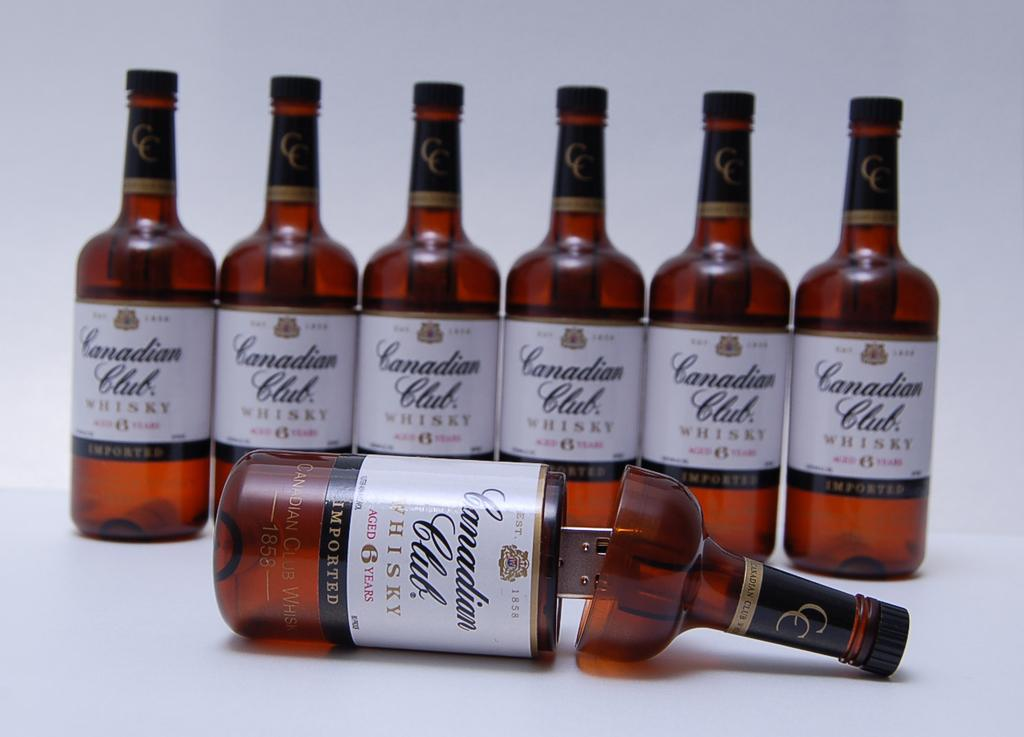<image>
Create a compact narrative representing the image presented. Six bottles of canadian club branded bottles that inside them hold USB thumb drives. 